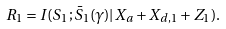<formula> <loc_0><loc_0><loc_500><loc_500>R _ { 1 } = I ( S _ { 1 } ; \bar { S } _ { 1 } ( \gamma ) | X _ { a } + X _ { d , 1 } + Z _ { 1 } ) .</formula> 